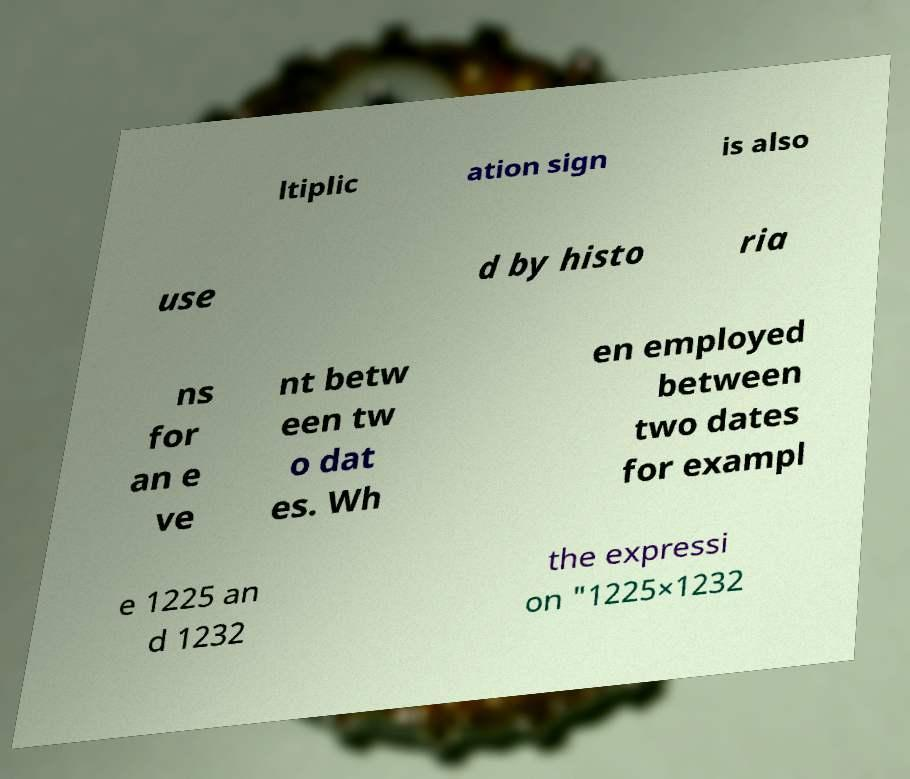Can you accurately transcribe the text from the provided image for me? ltiplic ation sign is also use d by histo ria ns for an e ve nt betw een tw o dat es. Wh en employed between two dates for exampl e 1225 an d 1232 the expressi on "1225×1232 